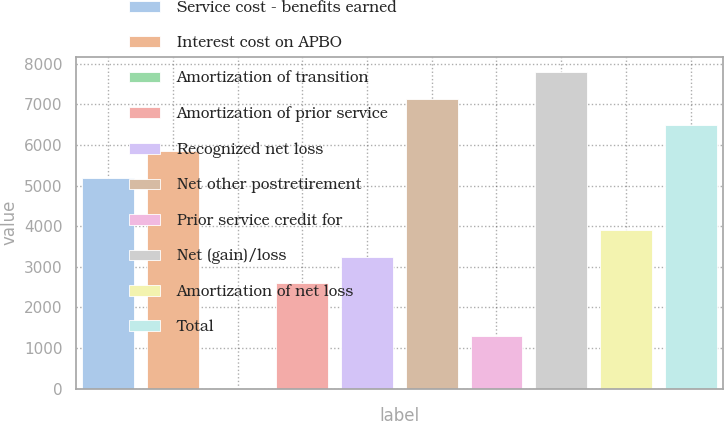Convert chart to OTSL. <chart><loc_0><loc_0><loc_500><loc_500><bar_chart><fcel>Service cost - benefits earned<fcel>Interest cost on APBO<fcel>Amortization of transition<fcel>Amortization of prior service<fcel>Recognized net loss<fcel>Net other postretirement<fcel>Prior service credit for<fcel>Net (gain)/loss<fcel>Amortization of net loss<fcel>Total<nl><fcel>5194.4<fcel>5842.7<fcel>8<fcel>2601.2<fcel>3249.5<fcel>7139.3<fcel>1304.6<fcel>7787.6<fcel>3897.8<fcel>6491<nl></chart> 